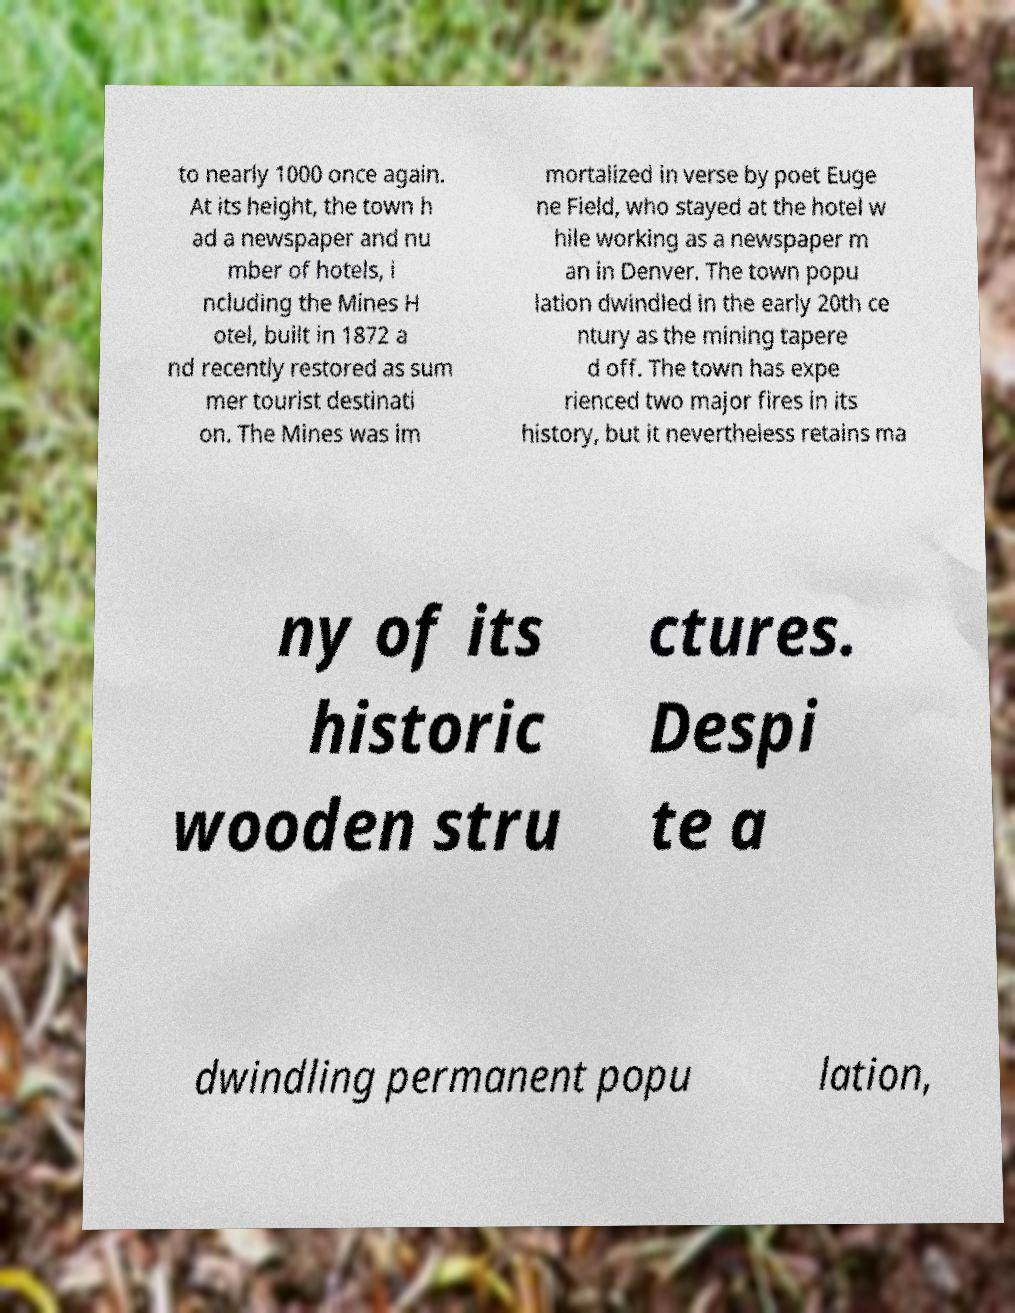There's text embedded in this image that I need extracted. Can you transcribe it verbatim? to nearly 1000 once again. At its height, the town h ad a newspaper and nu mber of hotels, i ncluding the Mines H otel, built in 1872 a nd recently restored as sum mer tourist destinati on. The Mines was im mortalized in verse by poet Euge ne Field, who stayed at the hotel w hile working as a newspaper m an in Denver. The town popu lation dwindled in the early 20th ce ntury as the mining tapere d off. The town has expe rienced two major fires in its history, but it nevertheless retains ma ny of its historic wooden stru ctures. Despi te a dwindling permanent popu lation, 